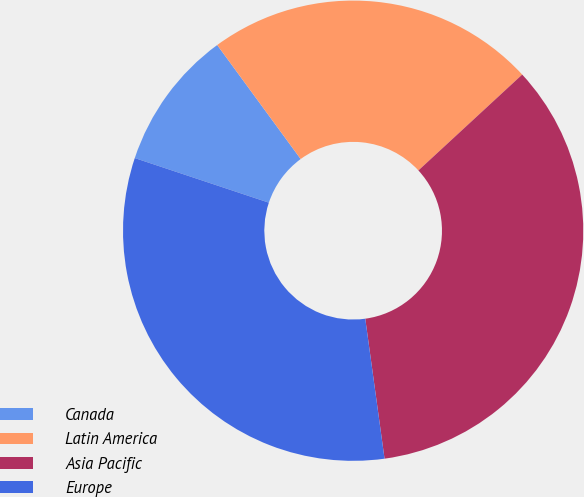<chart> <loc_0><loc_0><loc_500><loc_500><pie_chart><fcel>Canada<fcel>Latin America<fcel>Asia Pacific<fcel>Europe<nl><fcel>9.83%<fcel>23.19%<fcel>34.69%<fcel>32.29%<nl></chart> 